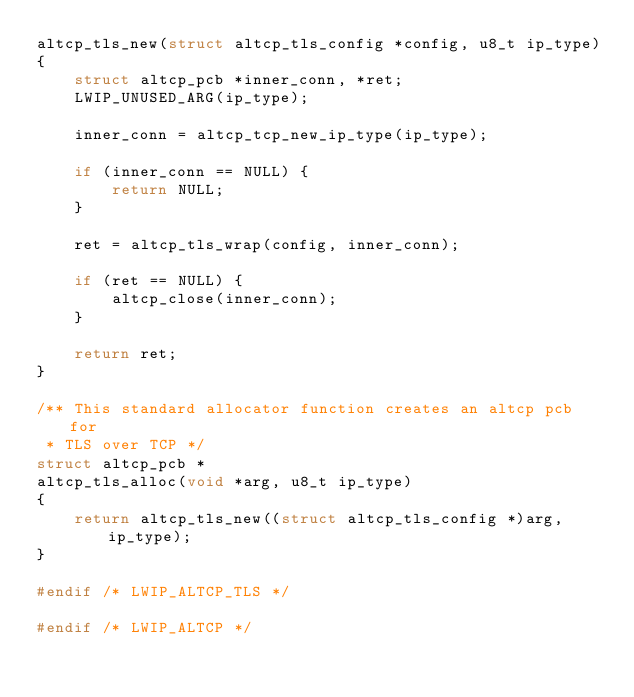Convert code to text. <code><loc_0><loc_0><loc_500><loc_500><_C_>altcp_tls_new(struct altcp_tls_config *config, u8_t ip_type)
{
    struct altcp_pcb *inner_conn, *ret;
    LWIP_UNUSED_ARG(ip_type);

    inner_conn = altcp_tcp_new_ip_type(ip_type);

    if (inner_conn == NULL) {
        return NULL;
    }

    ret = altcp_tls_wrap(config, inner_conn);

    if (ret == NULL) {
        altcp_close(inner_conn);
    }

    return ret;
}

/** This standard allocator function creates an altcp pcb for
 * TLS over TCP */
struct altcp_pcb *
altcp_tls_alloc(void *arg, u8_t ip_type)
{
    return altcp_tls_new((struct altcp_tls_config *)arg, ip_type);
}

#endif /* LWIP_ALTCP_TLS */

#endif /* LWIP_ALTCP */
</code> 